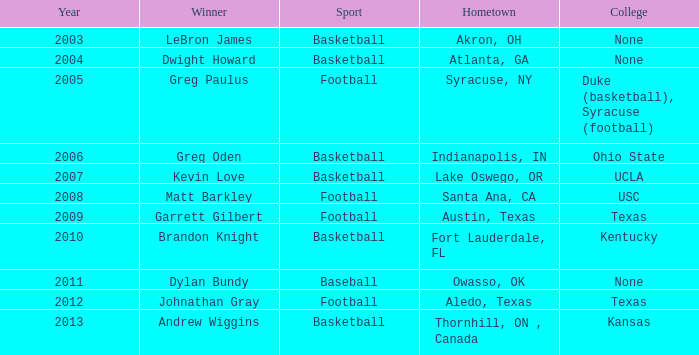In the context of "basketball" and "dwight howard" as the victor, what is the hometown? Atlanta, GA. 